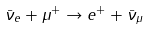Convert formula to latex. <formula><loc_0><loc_0><loc_500><loc_500>\bar { \nu } _ { e } + \mu ^ { + } \rightarrow e ^ { + } + \bar { \nu } _ { \mu }</formula> 